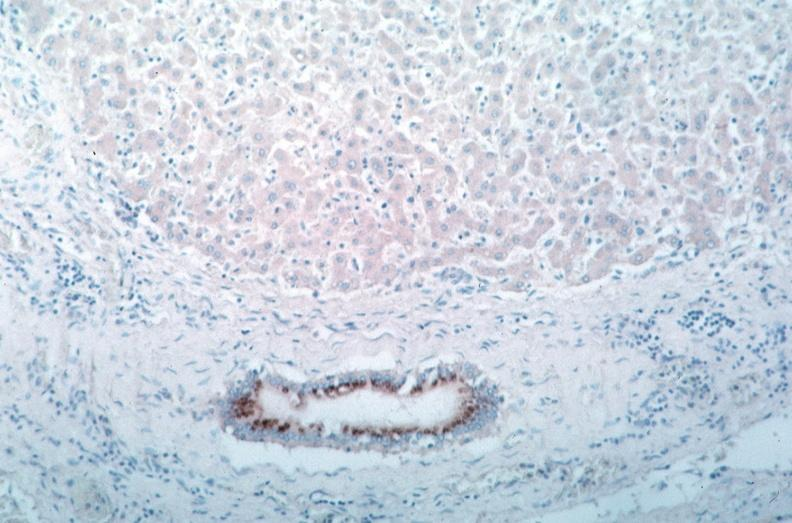s coronary artery present?
Answer the question using a single word or phrase. No 